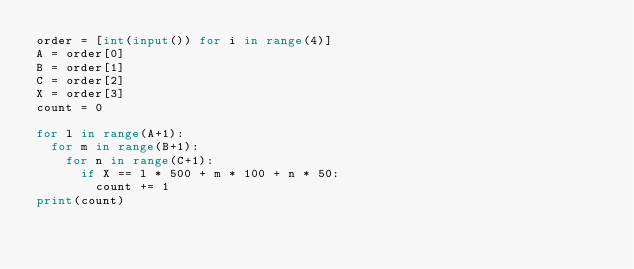Convert code to text. <code><loc_0><loc_0><loc_500><loc_500><_Python_>order = [int(input()) for i in range(4)]
A = order[0]
B = order[1]
C = order[2]
X = order[3]
count = 0

for l in range(A+1):
  for m in range(B+1):
    for n in range(C+1):
      if X == l * 500 + m * 100 + n * 50:
        count += 1
print(count)     
</code> 